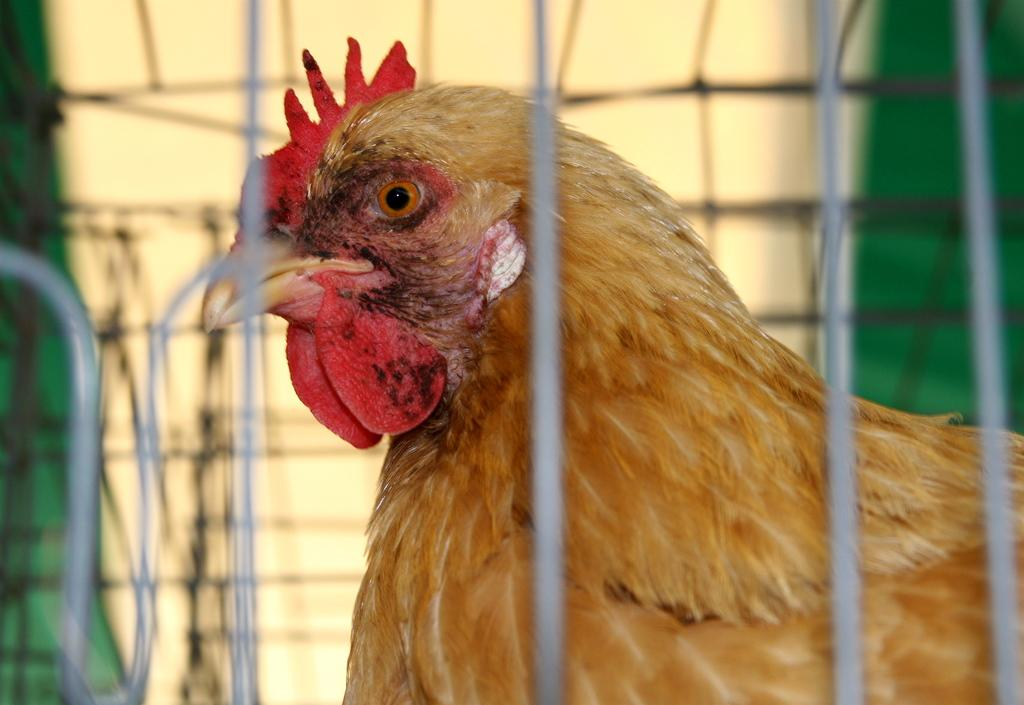What type of animal is in the cage in the image? There is a brown color hen in a cage in the image. What color is the wall in the background of the image? The wall in the background of the image is yellow. What other color can be seen in the background of the image? There is a green color sheet in the background of the image. What type of nut is being used to open the cage in the image? There is no nut present in the image, and the cage is not being opened. 